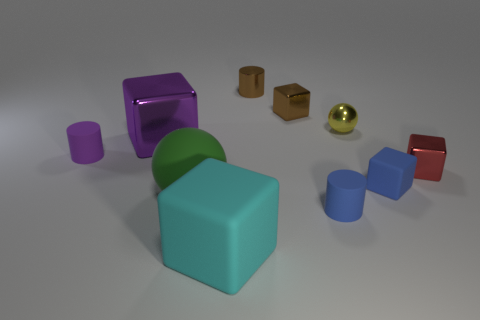There is a yellow thing that is the same size as the metallic cylinder; what is its material?
Ensure brevity in your answer.  Metal. What material is the sphere behind the tiny red object?
Offer a terse response. Metal. There is a matte object that is both behind the rubber sphere and to the right of the purple rubber cylinder; what is its size?
Give a very brief answer. Small. How big is the ball that is in front of the matte object on the left side of the big cube behind the red object?
Your answer should be compact. Large. How many other things are the same color as the big rubber cube?
Your answer should be compact. 0. Does the rubber cylinder that is on the right side of the cyan thing have the same color as the tiny rubber block?
Offer a terse response. Yes. How many objects are either tiny blue metallic cubes or small blue rubber objects?
Offer a terse response. 2. There is a rubber block to the right of the yellow metal ball; what is its color?
Your answer should be compact. Blue. Are there fewer big blocks that are in front of the tiny purple object than big green objects?
Offer a very short reply. No. The cylinder that is the same color as the small rubber cube is what size?
Offer a very short reply. Small. 